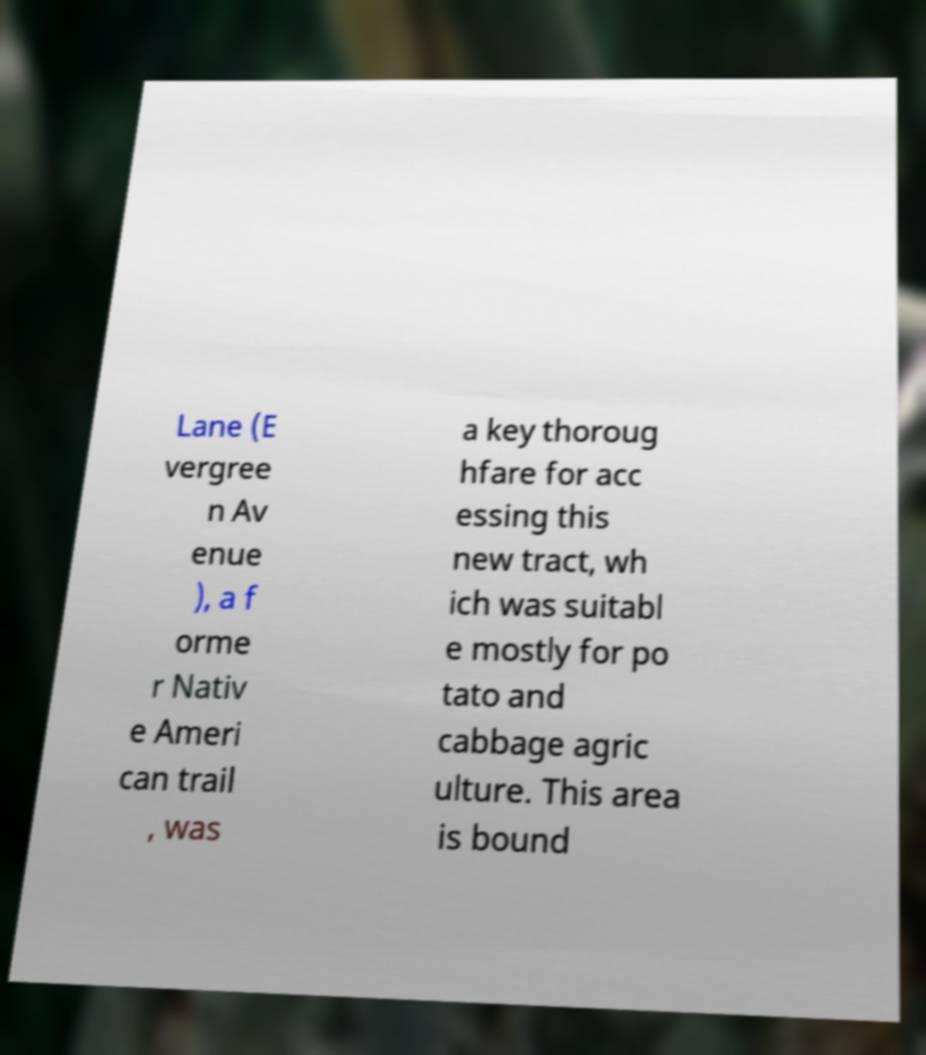Please read and relay the text visible in this image. What does it say? Lane (E vergree n Av enue ), a f orme r Nativ e Ameri can trail , was a key thoroug hfare for acc essing this new tract, wh ich was suitabl e mostly for po tato and cabbage agric ulture. This area is bound 